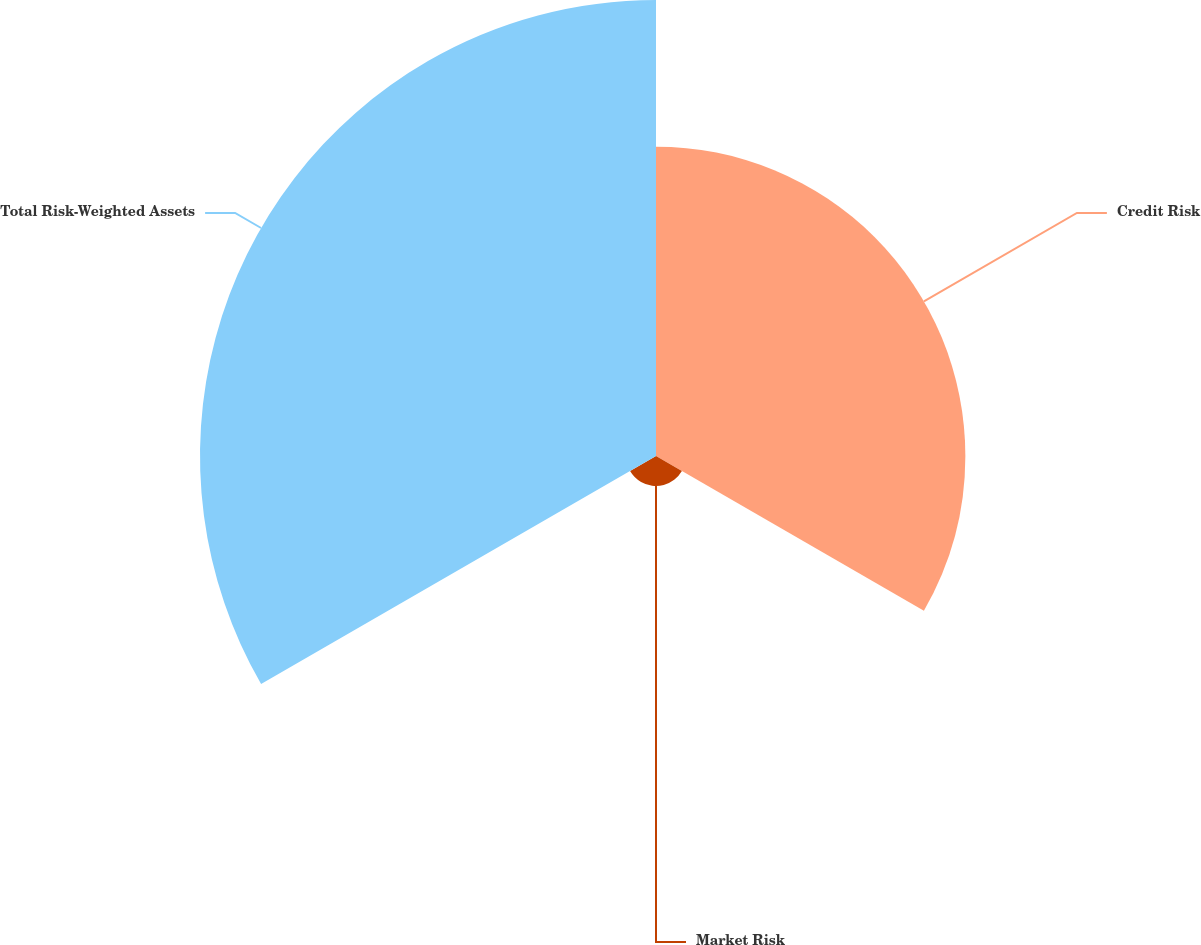Convert chart to OTSL. <chart><loc_0><loc_0><loc_500><loc_500><pie_chart><fcel>Credit Risk<fcel>Market Risk<fcel>Total Risk-Weighted Assets<nl><fcel>38.9%<fcel>3.76%<fcel>57.34%<nl></chart> 